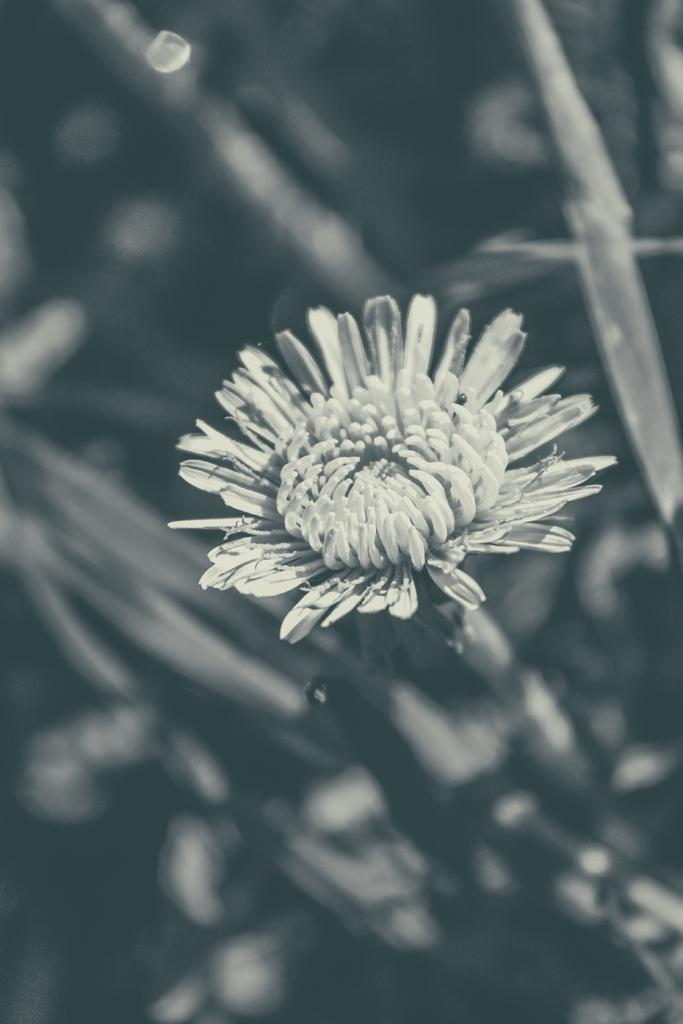What is the color scheme of the image? The image is black and white. What type of plant is featured in the image? There is a flower with petals in the image. Can you describe the background of the image? The background of the image appears blurry. How many cows can be seen wearing stockings in the image? There are no cows or stockings present in the image. 